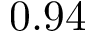Convert formula to latex. <formula><loc_0><loc_0><loc_500><loc_500>0 . 9 4</formula> 